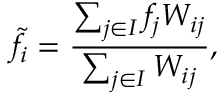<formula> <loc_0><loc_0><loc_500><loc_500>\widetilde { f } _ { i } = \frac { \sum _ { j \in I } f _ { j } W _ { i j } } { \sum _ { j \in I } W _ { i j } } ,</formula> 